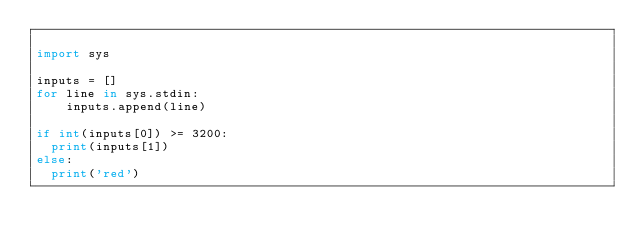<code> <loc_0><loc_0><loc_500><loc_500><_Python_>
import sys
 
inputs = []
for line in sys.stdin:
    inputs.append(line)
    
if int(inputs[0]) >= 3200:
  print(inputs[1])
else:
  print('red')</code> 